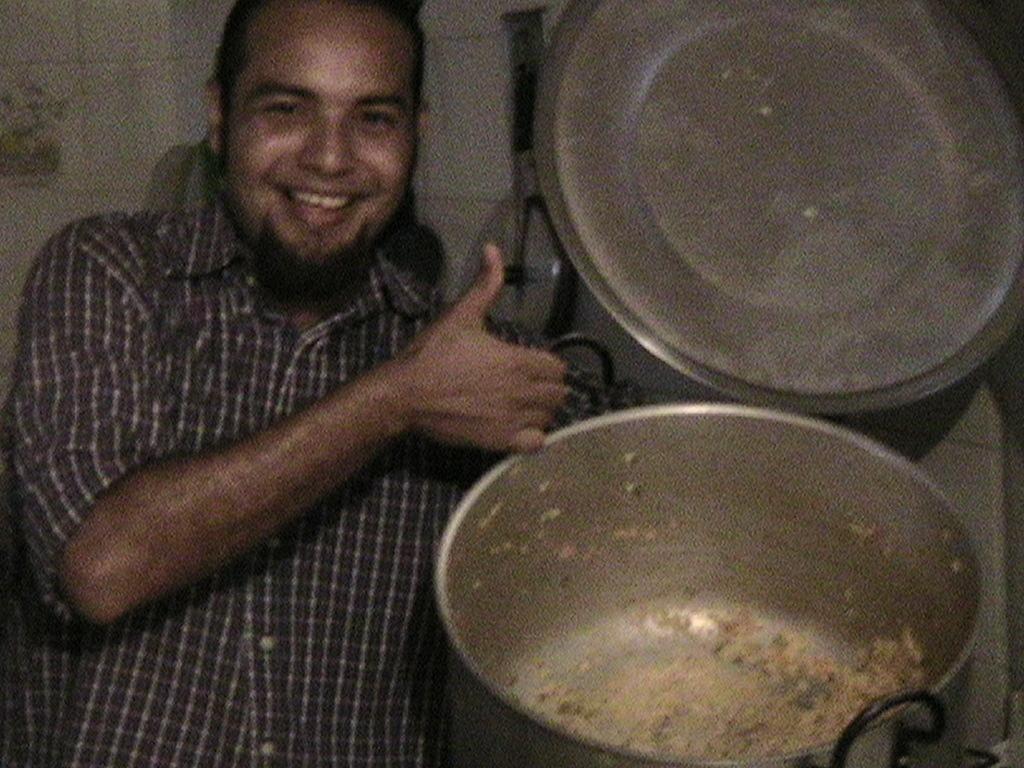Can you describe this image briefly? In this image there is a man showing the vessel by opening its cap. In the vessel there is some food. 